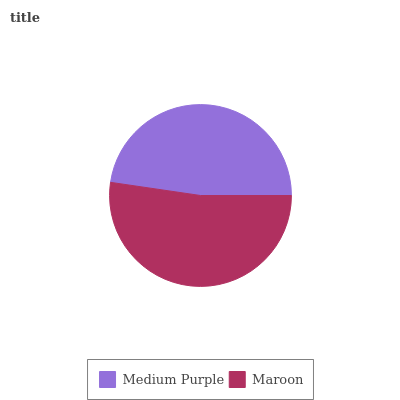Is Medium Purple the minimum?
Answer yes or no. Yes. Is Maroon the maximum?
Answer yes or no. Yes. Is Maroon the minimum?
Answer yes or no. No. Is Maroon greater than Medium Purple?
Answer yes or no. Yes. Is Medium Purple less than Maroon?
Answer yes or no. Yes. Is Medium Purple greater than Maroon?
Answer yes or no. No. Is Maroon less than Medium Purple?
Answer yes or no. No. Is Maroon the high median?
Answer yes or no. Yes. Is Medium Purple the low median?
Answer yes or no. Yes. Is Medium Purple the high median?
Answer yes or no. No. Is Maroon the low median?
Answer yes or no. No. 